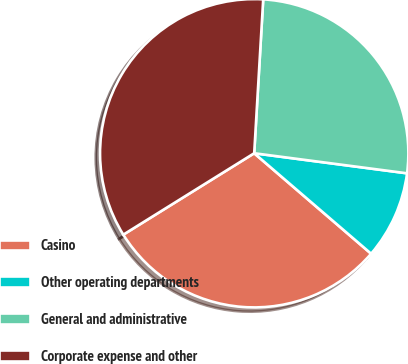Convert chart to OTSL. <chart><loc_0><loc_0><loc_500><loc_500><pie_chart><fcel>Casino<fcel>Other operating departments<fcel>General and administrative<fcel>Corporate expense and other<nl><fcel>29.85%<fcel>9.22%<fcel>26.15%<fcel>34.79%<nl></chart> 